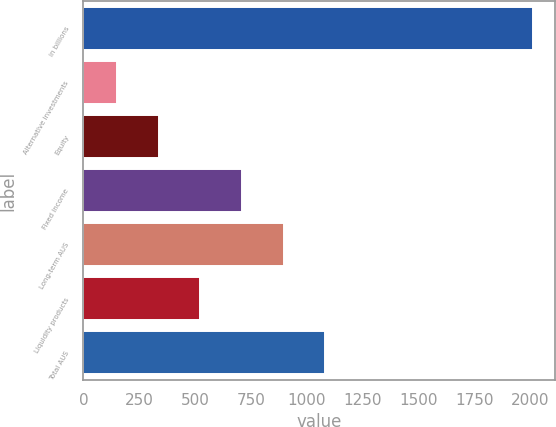Convert chart. <chart><loc_0><loc_0><loc_500><loc_500><bar_chart><fcel>in billions<fcel>Alternative investments<fcel>Equity<fcel>Fixed income<fcel>Long-term AUS<fcel>Liquidity products<fcel>Total AUS<nl><fcel>2011<fcel>152<fcel>337.9<fcel>709.7<fcel>895.6<fcel>523.8<fcel>1081.5<nl></chart> 